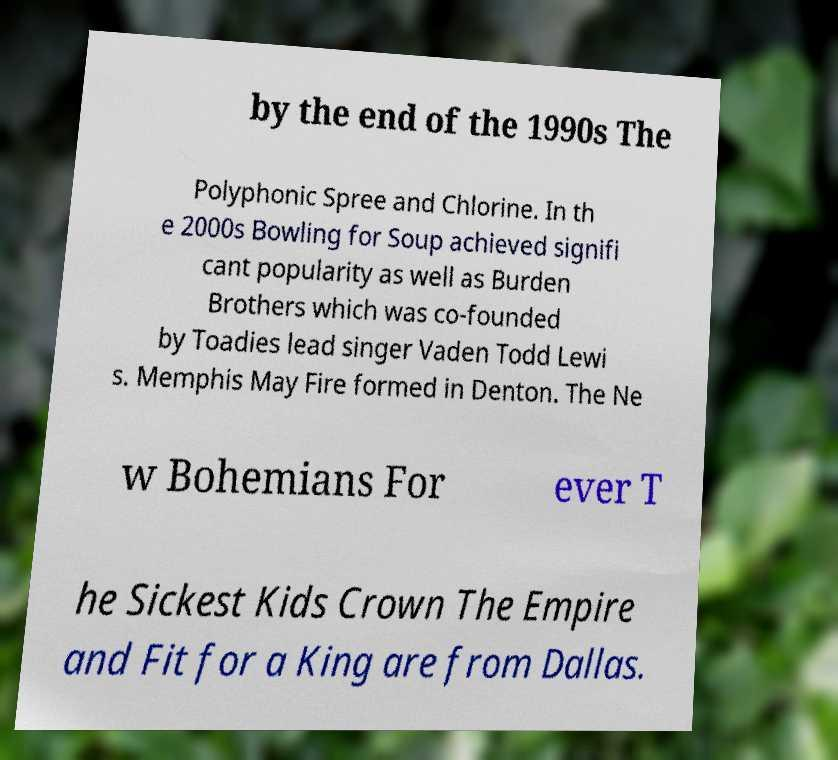Could you extract and type out the text from this image? by the end of the 1990s The Polyphonic Spree and Chlorine. In th e 2000s Bowling for Soup achieved signifi cant popularity as well as Burden Brothers which was co-founded by Toadies lead singer Vaden Todd Lewi s. Memphis May Fire formed in Denton. The Ne w Bohemians For ever T he Sickest Kids Crown The Empire and Fit for a King are from Dallas. 